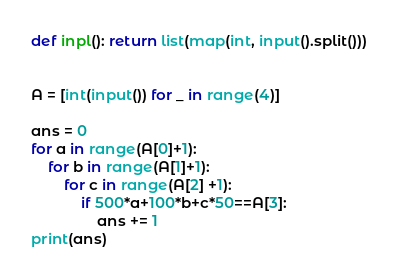<code> <loc_0><loc_0><loc_500><loc_500><_Python_>def inpl(): return list(map(int, input().split()))


A = [int(input()) for _ in range(4)]

ans = 0
for a in range(A[0]+1):
    for b in range(A[1]+1):
        for c in range(A[2] +1):
            if 500*a+100*b+c*50==A[3]:
                ans += 1
print(ans)
</code> 